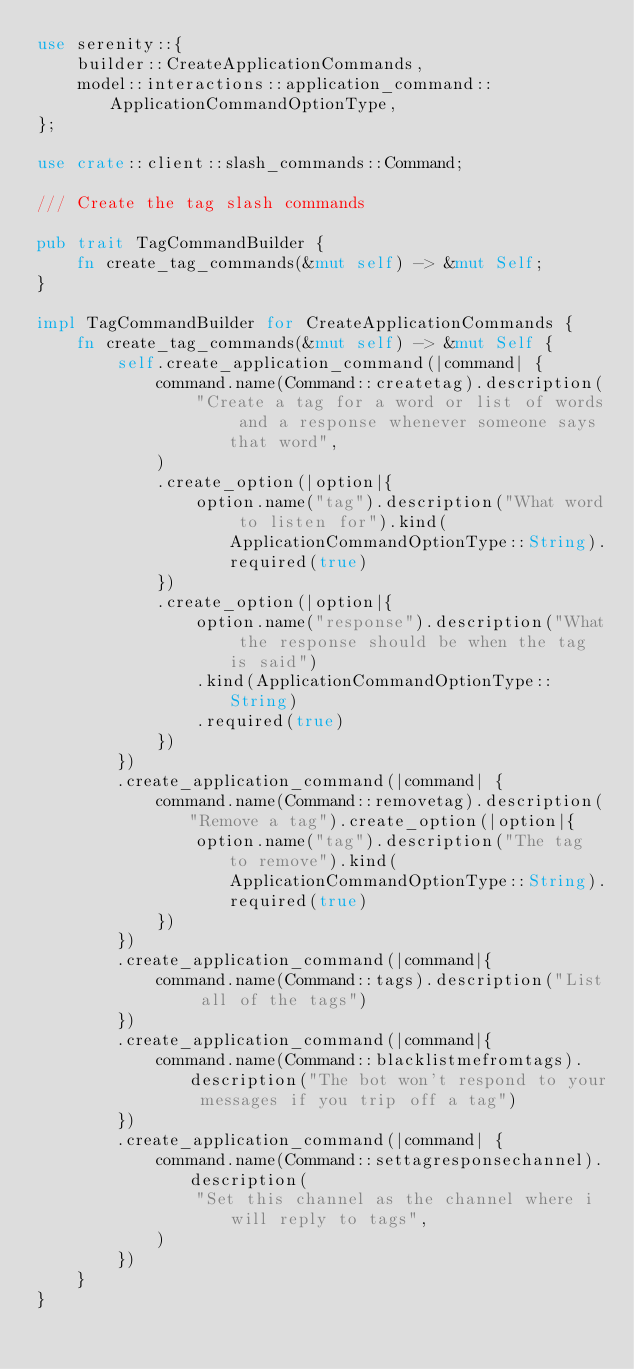<code> <loc_0><loc_0><loc_500><loc_500><_Rust_>use serenity::{
    builder::CreateApplicationCommands,
    model::interactions::application_command::ApplicationCommandOptionType,
};

use crate::client::slash_commands::Command;

/// Create the tag slash commands

pub trait TagCommandBuilder {
    fn create_tag_commands(&mut self) -> &mut Self;
}

impl TagCommandBuilder for CreateApplicationCommands {
    fn create_tag_commands(&mut self) -> &mut Self {
        self.create_application_command(|command| {
            command.name(Command::createtag).description(
                "Create a tag for a word or list of words and a response whenever someone says that word",
            )
            .create_option(|option|{
                option.name("tag").description("What word to listen for").kind(ApplicationCommandOptionType::String).required(true)
            })
            .create_option(|option|{
                option.name("response").description("What the response should be when the tag is said")
                .kind(ApplicationCommandOptionType::String)
                .required(true)
            })
        })
        .create_application_command(|command| {
            command.name(Command::removetag).description("Remove a tag").create_option(|option|{
                option.name("tag").description("The tag to remove").kind(ApplicationCommandOptionType::String).required(true)
            })
        })
        .create_application_command(|command|{
            command.name(Command::tags).description("List all of the tags")
        })
        .create_application_command(|command|{
            command.name(Command::blacklistmefromtags).description("The bot won't respond to your messages if you trip off a tag")
        })
        .create_application_command(|command| {
            command.name(Command::settagresponsechannel).description(
                "Set this channel as the channel where i will reply to tags",
            )
        })
    }
}
</code> 